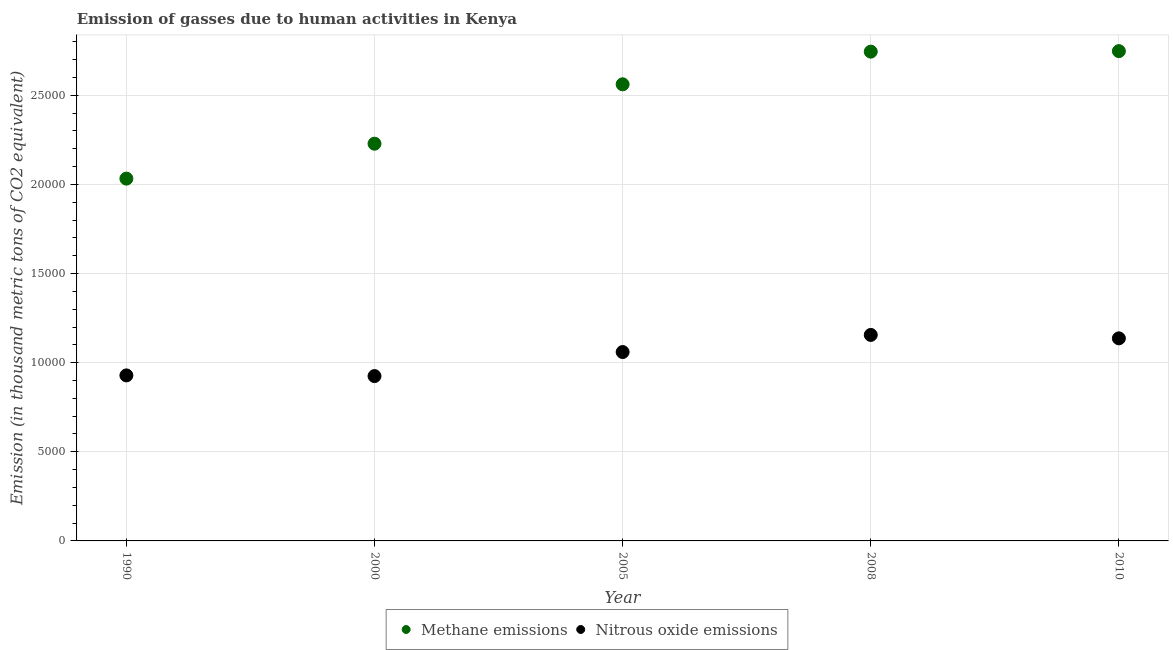How many different coloured dotlines are there?
Your response must be concise. 2. What is the amount of nitrous oxide emissions in 2000?
Your answer should be very brief. 9247.6. Across all years, what is the maximum amount of nitrous oxide emissions?
Offer a very short reply. 1.16e+04. Across all years, what is the minimum amount of methane emissions?
Provide a succinct answer. 2.03e+04. In which year was the amount of nitrous oxide emissions maximum?
Your answer should be very brief. 2008. In which year was the amount of methane emissions minimum?
Ensure brevity in your answer.  1990. What is the total amount of nitrous oxide emissions in the graph?
Your answer should be very brief. 5.21e+04. What is the difference between the amount of nitrous oxide emissions in 2005 and that in 2010?
Ensure brevity in your answer.  -767.8. What is the difference between the amount of methane emissions in 1990 and the amount of nitrous oxide emissions in 2008?
Your answer should be very brief. 8768. What is the average amount of nitrous oxide emissions per year?
Make the answer very short. 1.04e+04. In the year 2005, what is the difference between the amount of nitrous oxide emissions and amount of methane emissions?
Make the answer very short. -1.50e+04. In how many years, is the amount of nitrous oxide emissions greater than 11000 thousand metric tons?
Make the answer very short. 2. What is the ratio of the amount of methane emissions in 1990 to that in 2000?
Give a very brief answer. 0.91. Is the amount of methane emissions in 2005 less than that in 2008?
Keep it short and to the point. Yes. Is the difference between the amount of nitrous oxide emissions in 1990 and 2000 greater than the difference between the amount of methane emissions in 1990 and 2000?
Your answer should be very brief. Yes. What is the difference between the highest and the second highest amount of methane emissions?
Keep it short and to the point. 29.4. What is the difference between the highest and the lowest amount of nitrous oxide emissions?
Your answer should be very brief. 2308.7. Is the sum of the amount of nitrous oxide emissions in 1990 and 2000 greater than the maximum amount of methane emissions across all years?
Offer a terse response. No. Is the amount of methane emissions strictly greater than the amount of nitrous oxide emissions over the years?
Offer a very short reply. Yes. Is the amount of nitrous oxide emissions strictly less than the amount of methane emissions over the years?
Your answer should be very brief. Yes. How many years are there in the graph?
Make the answer very short. 5. What is the difference between two consecutive major ticks on the Y-axis?
Provide a short and direct response. 5000. How are the legend labels stacked?
Your answer should be very brief. Horizontal. What is the title of the graph?
Ensure brevity in your answer.  Emission of gasses due to human activities in Kenya. Does "Revenue" appear as one of the legend labels in the graph?
Give a very brief answer. No. What is the label or title of the X-axis?
Give a very brief answer. Year. What is the label or title of the Y-axis?
Offer a very short reply. Emission (in thousand metric tons of CO2 equivalent). What is the Emission (in thousand metric tons of CO2 equivalent) of Methane emissions in 1990?
Offer a very short reply. 2.03e+04. What is the Emission (in thousand metric tons of CO2 equivalent) of Nitrous oxide emissions in 1990?
Ensure brevity in your answer.  9285.7. What is the Emission (in thousand metric tons of CO2 equivalent) in Methane emissions in 2000?
Your answer should be very brief. 2.23e+04. What is the Emission (in thousand metric tons of CO2 equivalent) in Nitrous oxide emissions in 2000?
Ensure brevity in your answer.  9247.6. What is the Emission (in thousand metric tons of CO2 equivalent) of Methane emissions in 2005?
Your answer should be compact. 2.56e+04. What is the Emission (in thousand metric tons of CO2 equivalent) of Nitrous oxide emissions in 2005?
Provide a succinct answer. 1.06e+04. What is the Emission (in thousand metric tons of CO2 equivalent) of Methane emissions in 2008?
Provide a succinct answer. 2.74e+04. What is the Emission (in thousand metric tons of CO2 equivalent) of Nitrous oxide emissions in 2008?
Ensure brevity in your answer.  1.16e+04. What is the Emission (in thousand metric tons of CO2 equivalent) of Methane emissions in 2010?
Keep it short and to the point. 2.75e+04. What is the Emission (in thousand metric tons of CO2 equivalent) of Nitrous oxide emissions in 2010?
Your response must be concise. 1.14e+04. Across all years, what is the maximum Emission (in thousand metric tons of CO2 equivalent) of Methane emissions?
Offer a very short reply. 2.75e+04. Across all years, what is the maximum Emission (in thousand metric tons of CO2 equivalent) of Nitrous oxide emissions?
Your answer should be very brief. 1.16e+04. Across all years, what is the minimum Emission (in thousand metric tons of CO2 equivalent) in Methane emissions?
Offer a terse response. 2.03e+04. Across all years, what is the minimum Emission (in thousand metric tons of CO2 equivalent) of Nitrous oxide emissions?
Make the answer very short. 9247.6. What is the total Emission (in thousand metric tons of CO2 equivalent) of Methane emissions in the graph?
Your response must be concise. 1.23e+05. What is the total Emission (in thousand metric tons of CO2 equivalent) of Nitrous oxide emissions in the graph?
Ensure brevity in your answer.  5.21e+04. What is the difference between the Emission (in thousand metric tons of CO2 equivalent) in Methane emissions in 1990 and that in 2000?
Provide a short and direct response. -1959.7. What is the difference between the Emission (in thousand metric tons of CO2 equivalent) in Nitrous oxide emissions in 1990 and that in 2000?
Your answer should be compact. 38.1. What is the difference between the Emission (in thousand metric tons of CO2 equivalent) of Methane emissions in 1990 and that in 2005?
Your answer should be compact. -5291.2. What is the difference between the Emission (in thousand metric tons of CO2 equivalent) of Nitrous oxide emissions in 1990 and that in 2005?
Your answer should be compact. -1310.7. What is the difference between the Emission (in thousand metric tons of CO2 equivalent) of Methane emissions in 1990 and that in 2008?
Offer a very short reply. -7123.6. What is the difference between the Emission (in thousand metric tons of CO2 equivalent) of Nitrous oxide emissions in 1990 and that in 2008?
Provide a succinct answer. -2270.6. What is the difference between the Emission (in thousand metric tons of CO2 equivalent) in Methane emissions in 1990 and that in 2010?
Offer a terse response. -7153. What is the difference between the Emission (in thousand metric tons of CO2 equivalent) of Nitrous oxide emissions in 1990 and that in 2010?
Make the answer very short. -2078.5. What is the difference between the Emission (in thousand metric tons of CO2 equivalent) of Methane emissions in 2000 and that in 2005?
Your answer should be very brief. -3331.5. What is the difference between the Emission (in thousand metric tons of CO2 equivalent) in Nitrous oxide emissions in 2000 and that in 2005?
Provide a succinct answer. -1348.8. What is the difference between the Emission (in thousand metric tons of CO2 equivalent) in Methane emissions in 2000 and that in 2008?
Give a very brief answer. -5163.9. What is the difference between the Emission (in thousand metric tons of CO2 equivalent) in Nitrous oxide emissions in 2000 and that in 2008?
Ensure brevity in your answer.  -2308.7. What is the difference between the Emission (in thousand metric tons of CO2 equivalent) in Methane emissions in 2000 and that in 2010?
Offer a very short reply. -5193.3. What is the difference between the Emission (in thousand metric tons of CO2 equivalent) of Nitrous oxide emissions in 2000 and that in 2010?
Give a very brief answer. -2116.6. What is the difference between the Emission (in thousand metric tons of CO2 equivalent) in Methane emissions in 2005 and that in 2008?
Provide a succinct answer. -1832.4. What is the difference between the Emission (in thousand metric tons of CO2 equivalent) of Nitrous oxide emissions in 2005 and that in 2008?
Keep it short and to the point. -959.9. What is the difference between the Emission (in thousand metric tons of CO2 equivalent) in Methane emissions in 2005 and that in 2010?
Make the answer very short. -1861.8. What is the difference between the Emission (in thousand metric tons of CO2 equivalent) in Nitrous oxide emissions in 2005 and that in 2010?
Your answer should be very brief. -767.8. What is the difference between the Emission (in thousand metric tons of CO2 equivalent) in Methane emissions in 2008 and that in 2010?
Provide a short and direct response. -29.4. What is the difference between the Emission (in thousand metric tons of CO2 equivalent) in Nitrous oxide emissions in 2008 and that in 2010?
Make the answer very short. 192.1. What is the difference between the Emission (in thousand metric tons of CO2 equivalent) in Methane emissions in 1990 and the Emission (in thousand metric tons of CO2 equivalent) in Nitrous oxide emissions in 2000?
Offer a terse response. 1.11e+04. What is the difference between the Emission (in thousand metric tons of CO2 equivalent) of Methane emissions in 1990 and the Emission (in thousand metric tons of CO2 equivalent) of Nitrous oxide emissions in 2005?
Provide a succinct answer. 9727.9. What is the difference between the Emission (in thousand metric tons of CO2 equivalent) of Methane emissions in 1990 and the Emission (in thousand metric tons of CO2 equivalent) of Nitrous oxide emissions in 2008?
Give a very brief answer. 8768. What is the difference between the Emission (in thousand metric tons of CO2 equivalent) in Methane emissions in 1990 and the Emission (in thousand metric tons of CO2 equivalent) in Nitrous oxide emissions in 2010?
Your answer should be compact. 8960.1. What is the difference between the Emission (in thousand metric tons of CO2 equivalent) of Methane emissions in 2000 and the Emission (in thousand metric tons of CO2 equivalent) of Nitrous oxide emissions in 2005?
Provide a short and direct response. 1.17e+04. What is the difference between the Emission (in thousand metric tons of CO2 equivalent) in Methane emissions in 2000 and the Emission (in thousand metric tons of CO2 equivalent) in Nitrous oxide emissions in 2008?
Provide a succinct answer. 1.07e+04. What is the difference between the Emission (in thousand metric tons of CO2 equivalent) in Methane emissions in 2000 and the Emission (in thousand metric tons of CO2 equivalent) in Nitrous oxide emissions in 2010?
Provide a succinct answer. 1.09e+04. What is the difference between the Emission (in thousand metric tons of CO2 equivalent) of Methane emissions in 2005 and the Emission (in thousand metric tons of CO2 equivalent) of Nitrous oxide emissions in 2008?
Offer a terse response. 1.41e+04. What is the difference between the Emission (in thousand metric tons of CO2 equivalent) in Methane emissions in 2005 and the Emission (in thousand metric tons of CO2 equivalent) in Nitrous oxide emissions in 2010?
Your answer should be compact. 1.43e+04. What is the difference between the Emission (in thousand metric tons of CO2 equivalent) of Methane emissions in 2008 and the Emission (in thousand metric tons of CO2 equivalent) of Nitrous oxide emissions in 2010?
Ensure brevity in your answer.  1.61e+04. What is the average Emission (in thousand metric tons of CO2 equivalent) of Methane emissions per year?
Provide a succinct answer. 2.46e+04. What is the average Emission (in thousand metric tons of CO2 equivalent) in Nitrous oxide emissions per year?
Provide a succinct answer. 1.04e+04. In the year 1990, what is the difference between the Emission (in thousand metric tons of CO2 equivalent) of Methane emissions and Emission (in thousand metric tons of CO2 equivalent) of Nitrous oxide emissions?
Offer a terse response. 1.10e+04. In the year 2000, what is the difference between the Emission (in thousand metric tons of CO2 equivalent) of Methane emissions and Emission (in thousand metric tons of CO2 equivalent) of Nitrous oxide emissions?
Offer a very short reply. 1.30e+04. In the year 2005, what is the difference between the Emission (in thousand metric tons of CO2 equivalent) in Methane emissions and Emission (in thousand metric tons of CO2 equivalent) in Nitrous oxide emissions?
Your answer should be very brief. 1.50e+04. In the year 2008, what is the difference between the Emission (in thousand metric tons of CO2 equivalent) of Methane emissions and Emission (in thousand metric tons of CO2 equivalent) of Nitrous oxide emissions?
Your answer should be very brief. 1.59e+04. In the year 2010, what is the difference between the Emission (in thousand metric tons of CO2 equivalent) in Methane emissions and Emission (in thousand metric tons of CO2 equivalent) in Nitrous oxide emissions?
Provide a short and direct response. 1.61e+04. What is the ratio of the Emission (in thousand metric tons of CO2 equivalent) in Methane emissions in 1990 to that in 2000?
Give a very brief answer. 0.91. What is the ratio of the Emission (in thousand metric tons of CO2 equivalent) in Nitrous oxide emissions in 1990 to that in 2000?
Provide a succinct answer. 1. What is the ratio of the Emission (in thousand metric tons of CO2 equivalent) in Methane emissions in 1990 to that in 2005?
Keep it short and to the point. 0.79. What is the ratio of the Emission (in thousand metric tons of CO2 equivalent) of Nitrous oxide emissions in 1990 to that in 2005?
Offer a terse response. 0.88. What is the ratio of the Emission (in thousand metric tons of CO2 equivalent) of Methane emissions in 1990 to that in 2008?
Make the answer very short. 0.74. What is the ratio of the Emission (in thousand metric tons of CO2 equivalent) of Nitrous oxide emissions in 1990 to that in 2008?
Offer a terse response. 0.8. What is the ratio of the Emission (in thousand metric tons of CO2 equivalent) of Methane emissions in 1990 to that in 2010?
Make the answer very short. 0.74. What is the ratio of the Emission (in thousand metric tons of CO2 equivalent) in Nitrous oxide emissions in 1990 to that in 2010?
Offer a terse response. 0.82. What is the ratio of the Emission (in thousand metric tons of CO2 equivalent) in Methane emissions in 2000 to that in 2005?
Your response must be concise. 0.87. What is the ratio of the Emission (in thousand metric tons of CO2 equivalent) of Nitrous oxide emissions in 2000 to that in 2005?
Your answer should be very brief. 0.87. What is the ratio of the Emission (in thousand metric tons of CO2 equivalent) of Methane emissions in 2000 to that in 2008?
Offer a terse response. 0.81. What is the ratio of the Emission (in thousand metric tons of CO2 equivalent) of Nitrous oxide emissions in 2000 to that in 2008?
Make the answer very short. 0.8. What is the ratio of the Emission (in thousand metric tons of CO2 equivalent) in Methane emissions in 2000 to that in 2010?
Keep it short and to the point. 0.81. What is the ratio of the Emission (in thousand metric tons of CO2 equivalent) in Nitrous oxide emissions in 2000 to that in 2010?
Offer a very short reply. 0.81. What is the ratio of the Emission (in thousand metric tons of CO2 equivalent) of Methane emissions in 2005 to that in 2008?
Your answer should be compact. 0.93. What is the ratio of the Emission (in thousand metric tons of CO2 equivalent) in Nitrous oxide emissions in 2005 to that in 2008?
Ensure brevity in your answer.  0.92. What is the ratio of the Emission (in thousand metric tons of CO2 equivalent) of Methane emissions in 2005 to that in 2010?
Make the answer very short. 0.93. What is the ratio of the Emission (in thousand metric tons of CO2 equivalent) in Nitrous oxide emissions in 2005 to that in 2010?
Your answer should be very brief. 0.93. What is the ratio of the Emission (in thousand metric tons of CO2 equivalent) in Nitrous oxide emissions in 2008 to that in 2010?
Offer a very short reply. 1.02. What is the difference between the highest and the second highest Emission (in thousand metric tons of CO2 equivalent) in Methane emissions?
Provide a short and direct response. 29.4. What is the difference between the highest and the second highest Emission (in thousand metric tons of CO2 equivalent) in Nitrous oxide emissions?
Offer a very short reply. 192.1. What is the difference between the highest and the lowest Emission (in thousand metric tons of CO2 equivalent) of Methane emissions?
Offer a terse response. 7153. What is the difference between the highest and the lowest Emission (in thousand metric tons of CO2 equivalent) in Nitrous oxide emissions?
Your answer should be compact. 2308.7. 